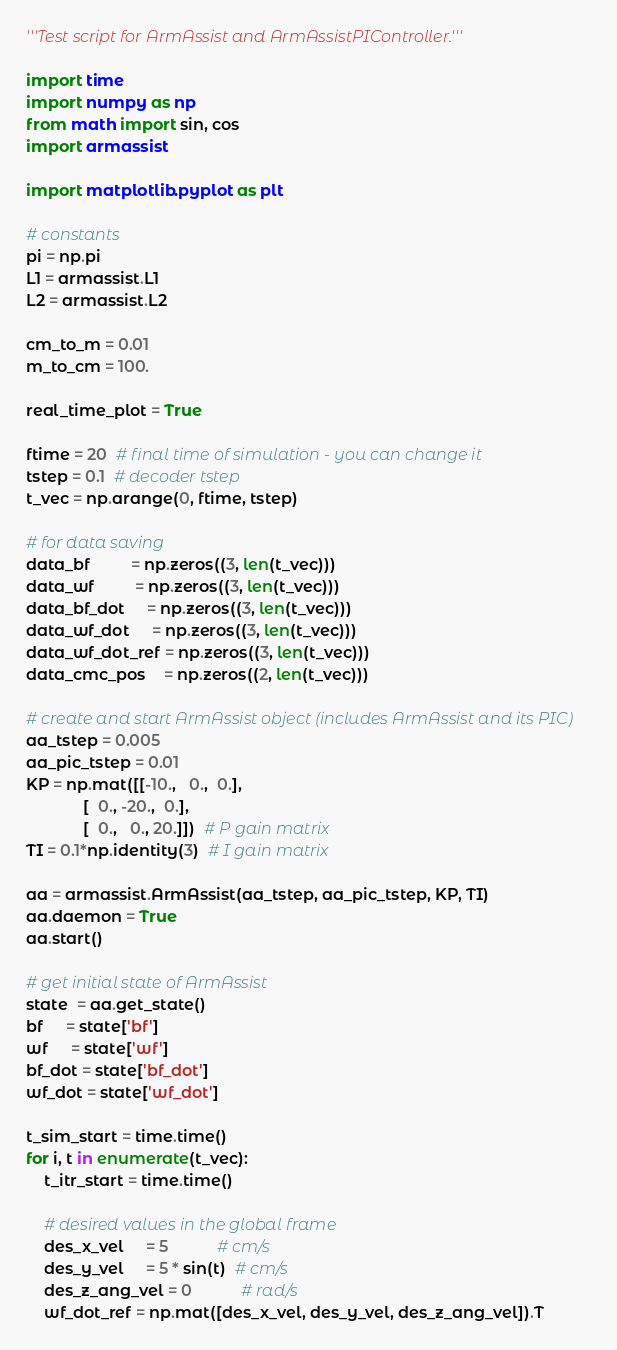Convert code to text. <code><loc_0><loc_0><loc_500><loc_500><_Python_>'''Test script for ArmAssist and ArmAssistPIController.'''

import time
import numpy as np
from math import sin, cos
import armassist

import matplotlib.pyplot as plt

# constants
pi = np.pi
L1 = armassist.L1
L2 = armassist.L2

cm_to_m = 0.01
m_to_cm = 100.

real_time_plot = True

ftime = 20  # final time of simulation - you can change it
tstep = 0.1  # decoder tstep
t_vec = np.arange(0, ftime, tstep)

# for data saving
data_bf         = np.zeros((3, len(t_vec)))
data_wf         = np.zeros((3, len(t_vec)))
data_bf_dot     = np.zeros((3, len(t_vec)))
data_wf_dot     = np.zeros((3, len(t_vec)))
data_wf_dot_ref = np.zeros((3, len(t_vec)))
data_cmc_pos    = np.zeros((2, len(t_vec)))

# create and start ArmAssist object (includes ArmAssist and its PIC)
aa_tstep = 0.005
aa_pic_tstep = 0.01
KP = np.mat([[-10.,   0.,  0.],
             [  0., -20.,  0.],
             [  0.,   0., 20.]])  # P gain matrix
TI = 0.1*np.identity(3)  # I gain matrix

aa = armassist.ArmAssist(aa_tstep, aa_pic_tstep, KP, TI)
aa.daemon = True
aa.start()

# get initial state of ArmAssist
state  = aa.get_state()
bf     = state['bf']
wf     = state['wf']
bf_dot = state['bf_dot']
wf_dot = state['wf_dot']

t_sim_start = time.time()
for i, t in enumerate(t_vec):
    t_itr_start = time.time()

    # desired values in the global frame
    des_x_vel     = 5           # cm/s
    des_y_vel     = 5 * sin(t)  # cm/s
    des_z_ang_vel = 0           # rad/s
    wf_dot_ref = np.mat([des_x_vel, des_y_vel, des_z_ang_vel]).T
</code> 